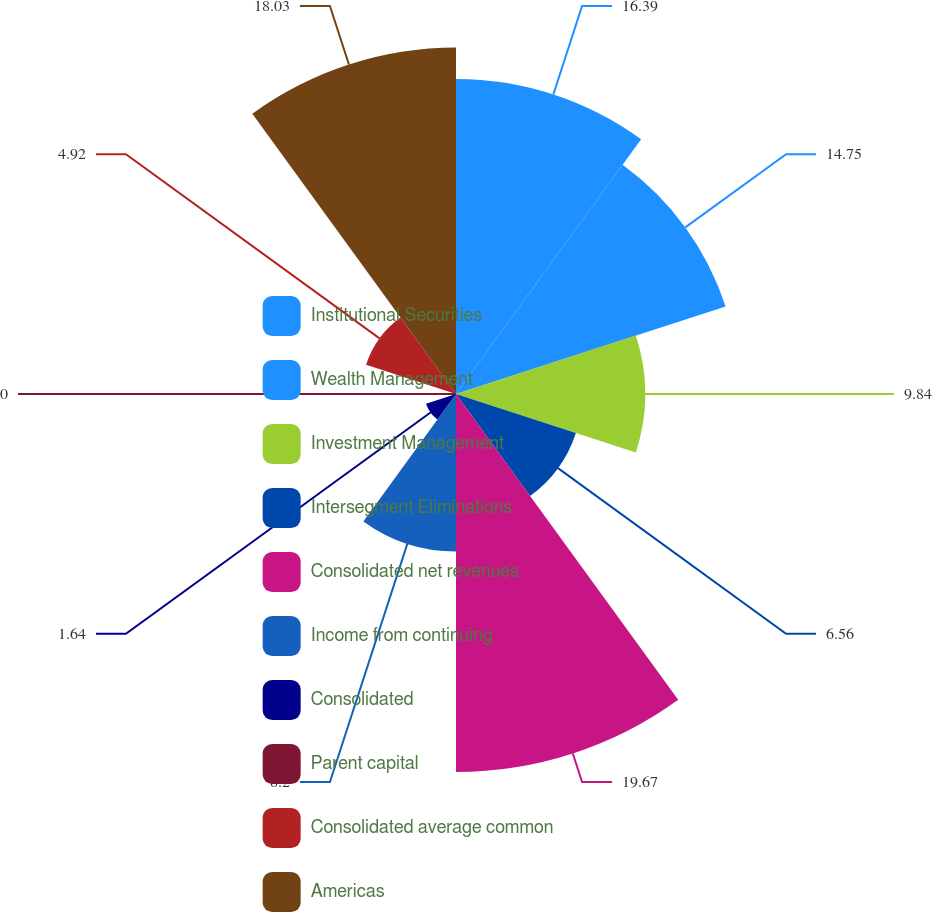Convert chart to OTSL. <chart><loc_0><loc_0><loc_500><loc_500><pie_chart><fcel>Institutional Securities<fcel>Wealth Management<fcel>Investment Management<fcel>Intersegment Eliminations<fcel>Consolidated net revenues<fcel>Income from continuing<fcel>Consolidated<fcel>Parent capital<fcel>Consolidated average common<fcel>Americas<nl><fcel>16.39%<fcel>14.75%<fcel>9.84%<fcel>6.56%<fcel>19.67%<fcel>8.2%<fcel>1.64%<fcel>0.0%<fcel>4.92%<fcel>18.03%<nl></chart> 